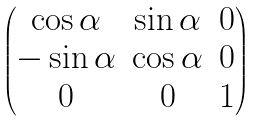<formula> <loc_0><loc_0><loc_500><loc_500>\begin{pmatrix} \cos \alpha & \sin \alpha & 0 \\ - \sin \alpha & \cos \alpha & 0 \\ 0 & 0 & 1 \end{pmatrix}</formula> 